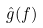Convert formula to latex. <formula><loc_0><loc_0><loc_500><loc_500>\hat { g } ( f )</formula> 